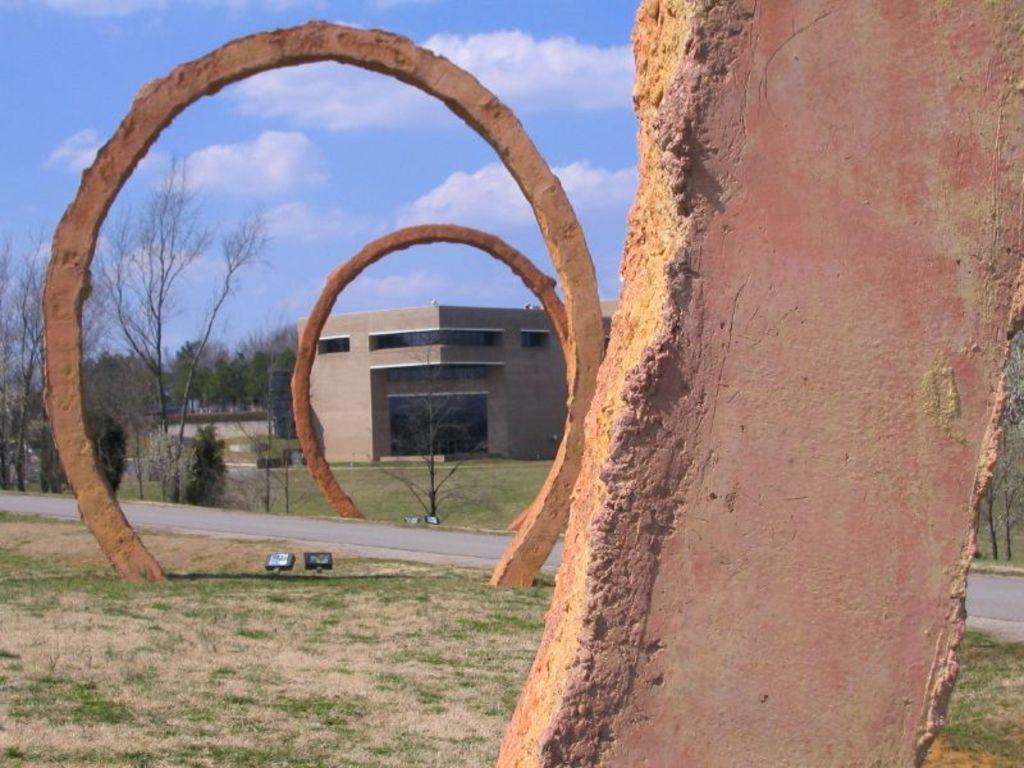Please provide a concise description of this image. In the foreground of the picture there are arches, grass, focus lights, road and trees. In the middle of the picture we can see trees, building and grass. At the top it is sky. 